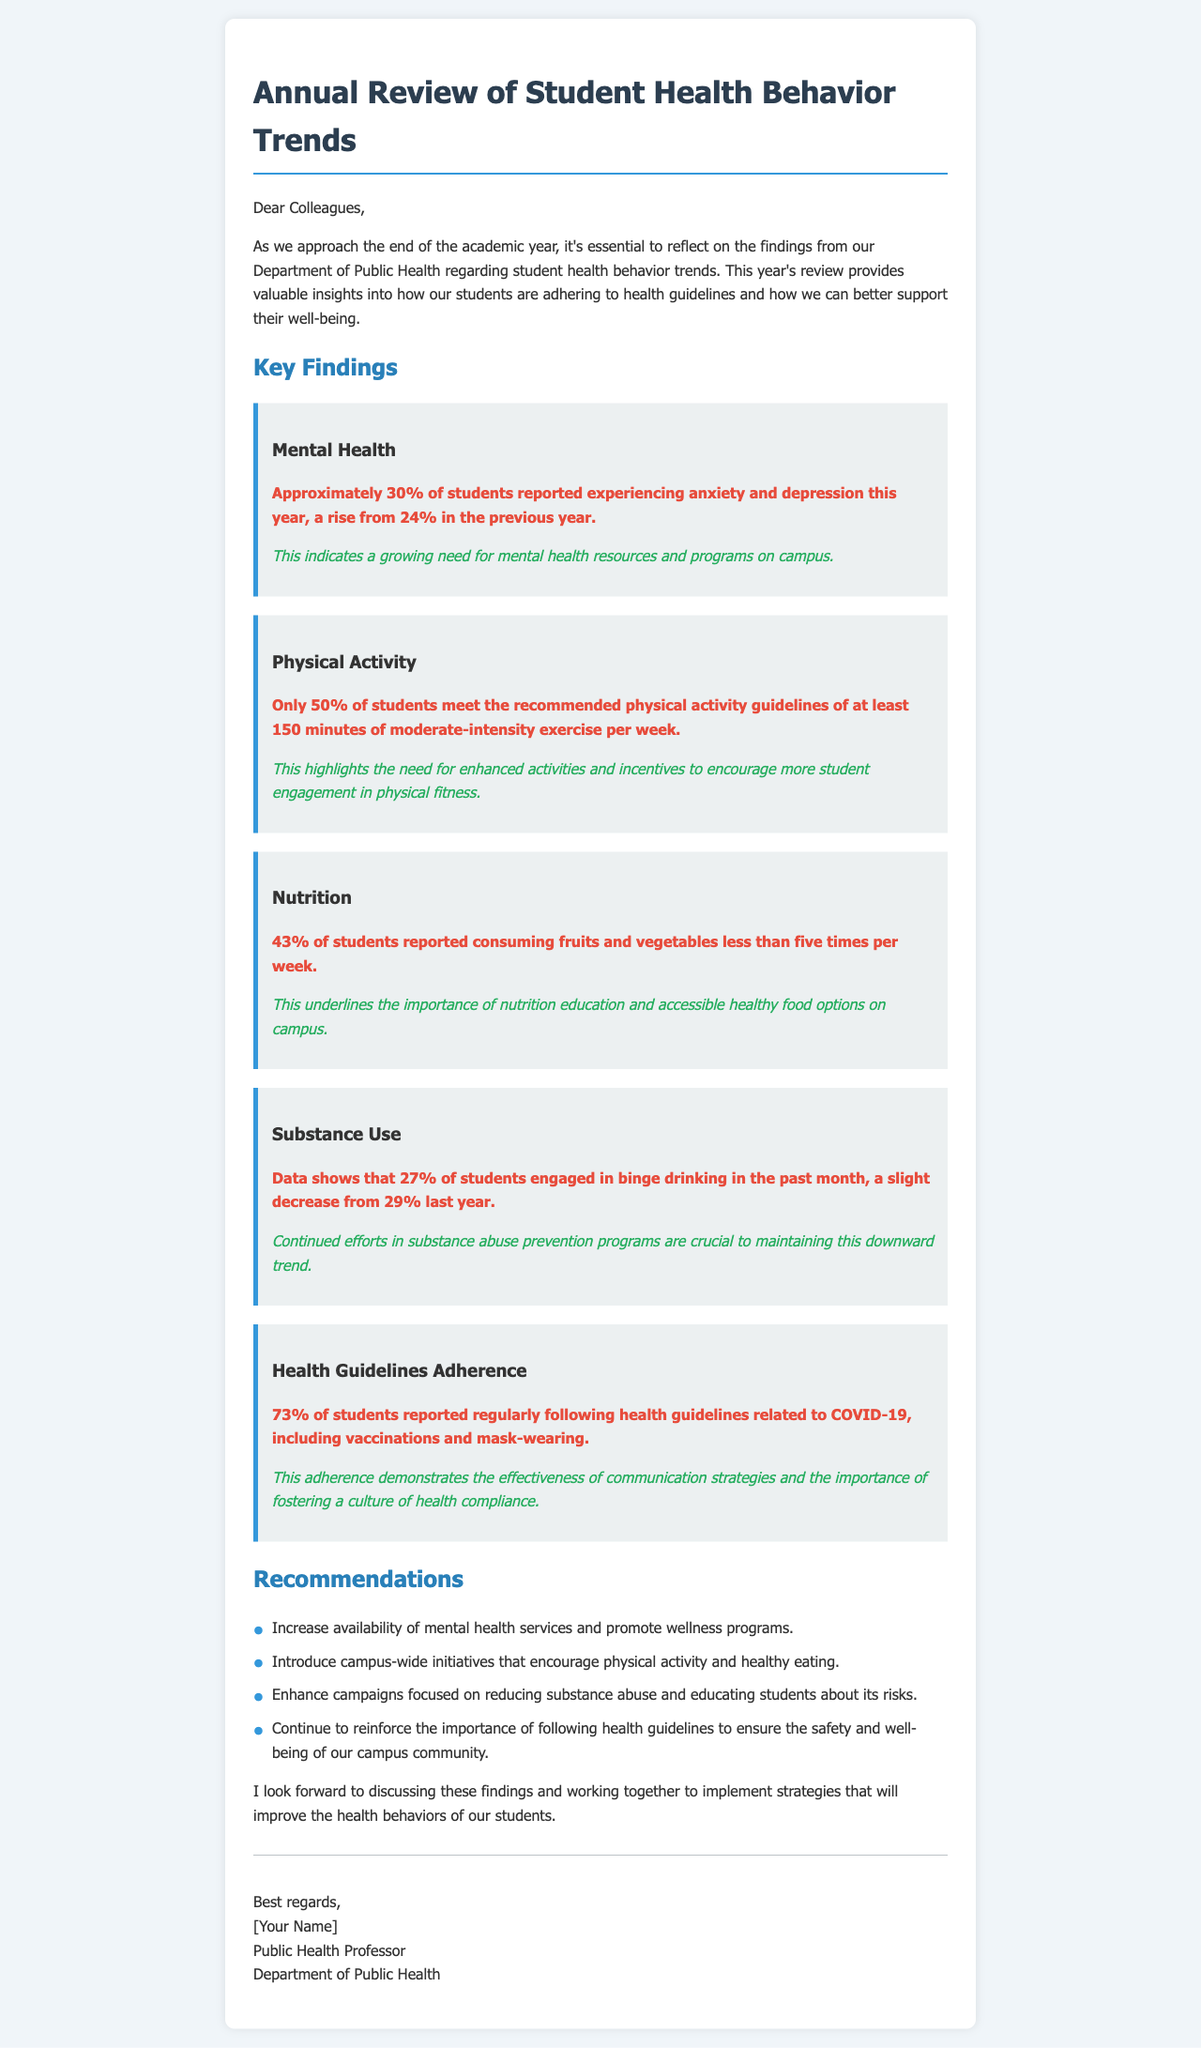What percentage of students reported experiencing anxiety and depression this year? The percentage of students reporting anxiety and depression this year is specified as approximately 30%.
Answer: 30% What is the recommended amount of physical activity per week? The document states that students are recommended to engage in at least 150 minutes of moderate-intensity exercise per week.
Answer: 150 minutes What percentage of students consume fruits and vegetables less than five times per week? The document explicitly mentions that 43% of students reported consuming fruits and vegetables less than five times per week.
Answer: 43% What is the percentage of students that followed health guidelines related to COVID-19? The adherence to health guidelines related to COVID-19 is noted as 73% of students.
Answer: 73% What implication is drawn from the increase in reported anxiety and depression among students? The implication noted is that there is a growing need for mental health resources and programs on campus.
Answer: Growing need for mental health resources What overall trend is highlighted regarding binge drinking among students? The document indicates a slight decrease in binge drinking, from 29% last year to 27% this year.
Answer: Slight decrease What is one key recommendation mentioned in the document? One of the recommendations suggests increasing the availability of mental health services.
Answer: Increase mental health services What does the document indicate about communication strategies related to health compliance? It remarks that adherence reflects the effectiveness of communication strategies regarding health compliance.
Answer: Effectiveness of communication strategies What is the document's main purpose? The primary purpose is to reflect on findings related to student health behavior trends at the end of the academic year.
Answer: Reflect on findings 